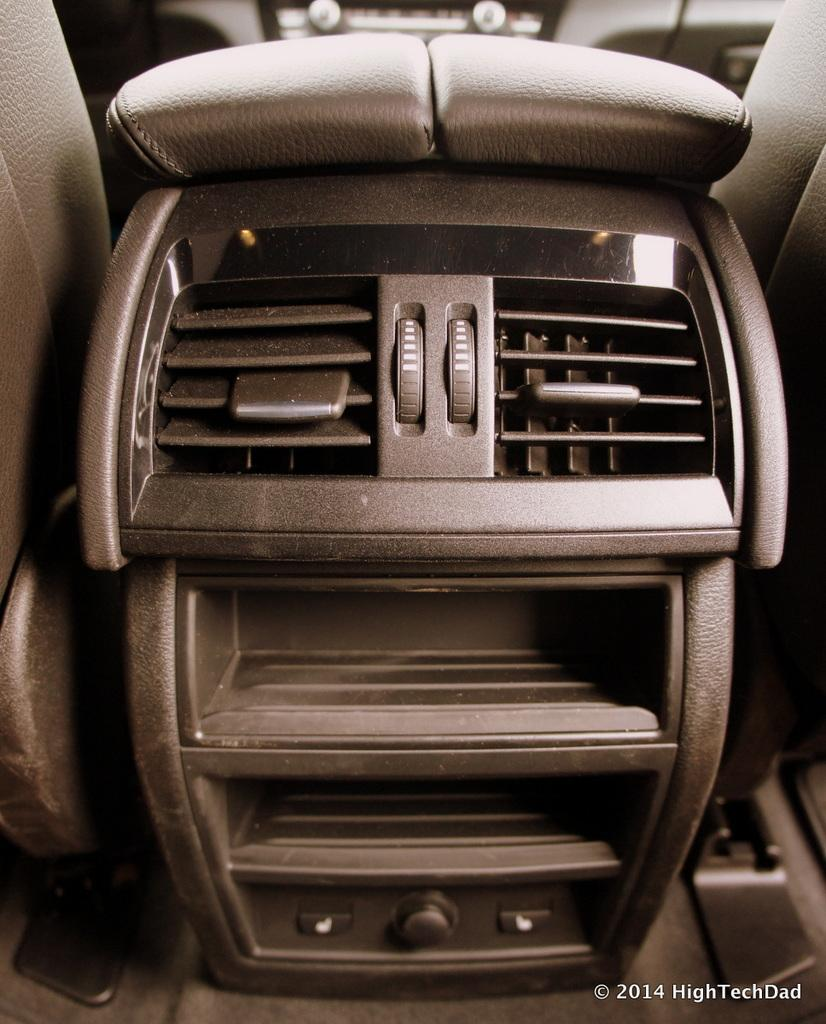What type of setting is depicted in the image? The image shows an inside view of a vehicle. What type of drug can be seen in the image? There is no drug present in the image; it shows an inside view of a vehicle. Can you describe the bees flying around the driver in the image? There are no bees present in the image; it shows an inside view of a vehicle. 